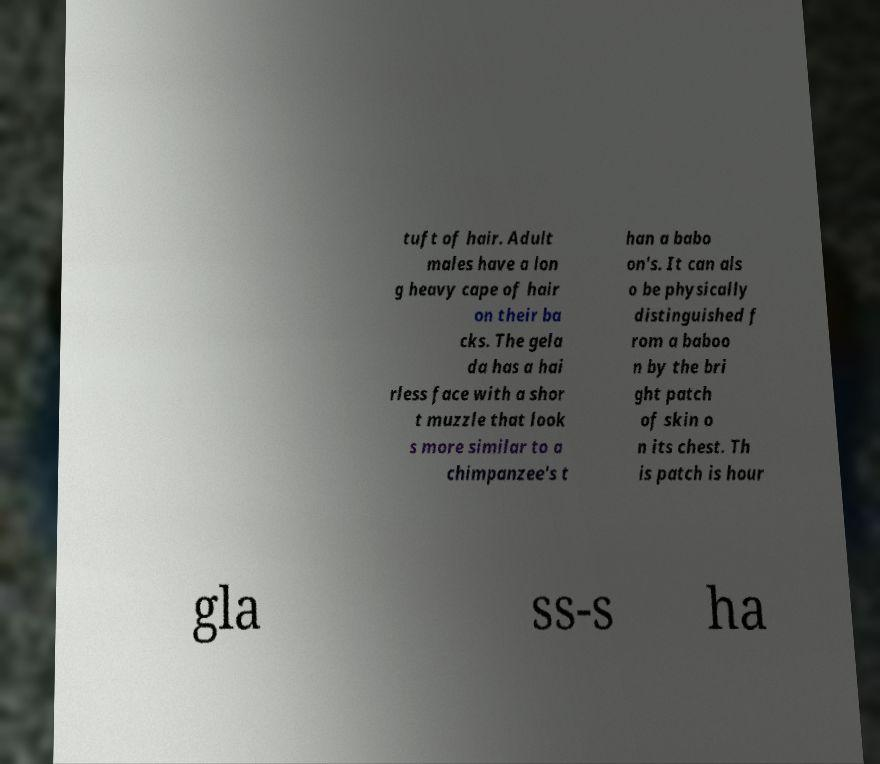I need the written content from this picture converted into text. Can you do that? tuft of hair. Adult males have a lon g heavy cape of hair on their ba cks. The gela da has a hai rless face with a shor t muzzle that look s more similar to a chimpanzee's t han a babo on's. It can als o be physically distinguished f rom a baboo n by the bri ght patch of skin o n its chest. Th is patch is hour gla ss-s ha 